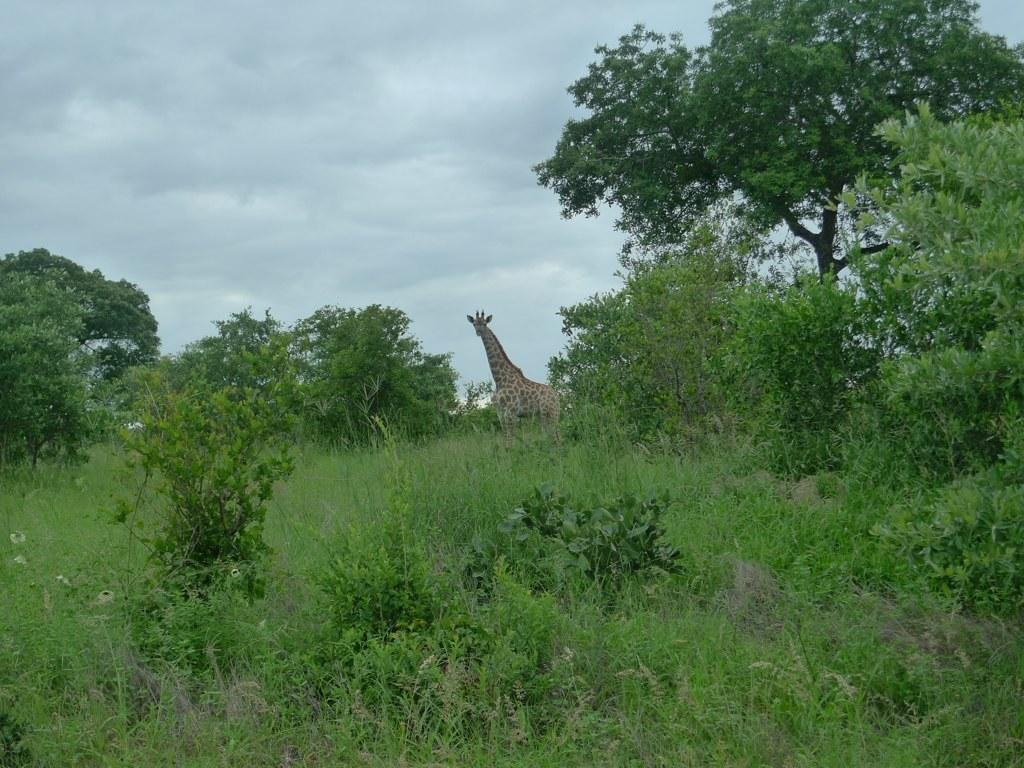What type of vegetation is present in the image? There are many trees, grass, and plants in the image. Can you describe the ground in the image? The ground is covered with grass. What animal can be seen in the background of the image? There is a giraffe standing on the grass in the background of the image. How many calculators can be seen in the image? There are no calculators present in the image. What type of government is depicted in the image? There is no depiction of a government in the image; it features trees, grass, plants, and a giraffe. 